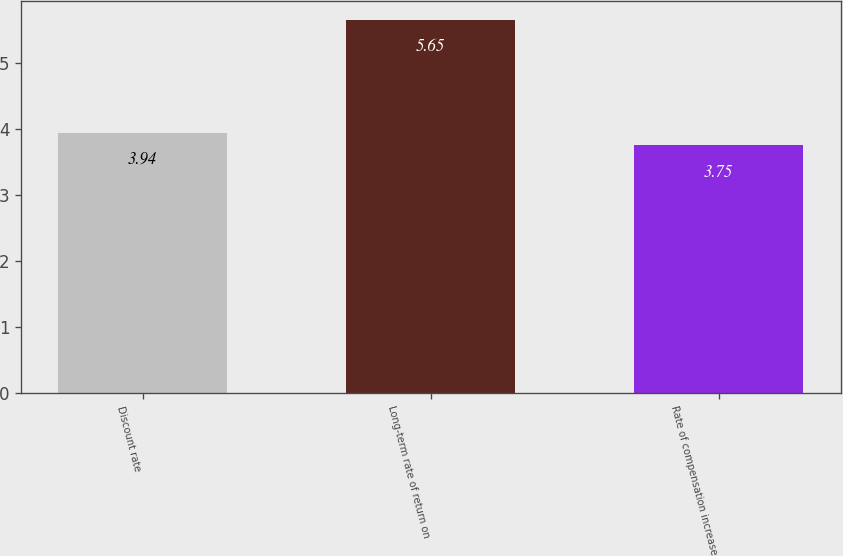Convert chart. <chart><loc_0><loc_0><loc_500><loc_500><bar_chart><fcel>Discount rate<fcel>Long-term rate of return on<fcel>Rate of compensation increase<nl><fcel>3.94<fcel>5.65<fcel>3.75<nl></chart> 